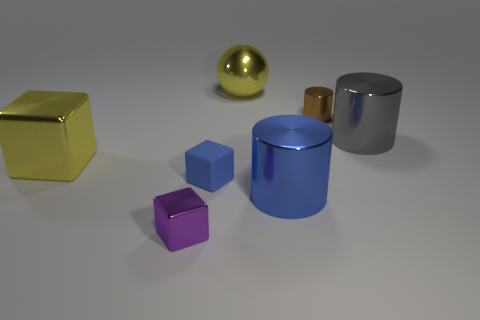What number of things are things that are right of the blue rubber object or tiny rubber cubes?
Make the answer very short. 5. Are there more yellow spheres that are behind the large ball than blue rubber blocks left of the small shiny block?
Your response must be concise. No. What number of rubber objects are big blue things or tiny purple blocks?
Provide a short and direct response. 0. There is another object that is the same color as the rubber thing; what is its material?
Give a very brief answer. Metal. Is the number of metallic cubes in front of the blue metallic object less than the number of brown metal things behind the tiny blue block?
Offer a very short reply. No. How many things are yellow metal cubes or large cylinders that are to the left of the gray metallic thing?
Your answer should be very brief. 2. What material is the sphere that is the same size as the gray shiny cylinder?
Provide a succinct answer. Metal. Is the material of the big blue cylinder the same as the large cube?
Provide a succinct answer. Yes. There is a large object that is in front of the large sphere and to the left of the large blue shiny object; what color is it?
Offer a terse response. Yellow. There is a tiny cube behind the large blue cylinder; does it have the same color as the large sphere?
Ensure brevity in your answer.  No. 